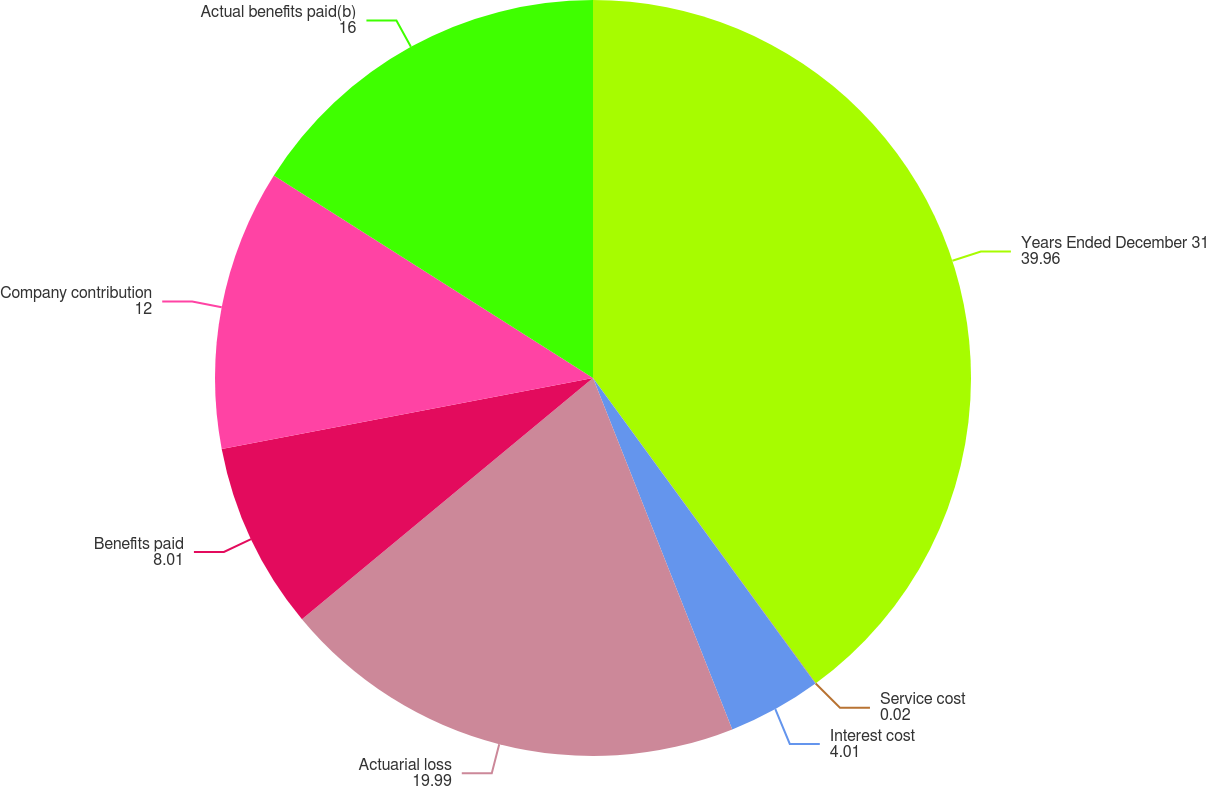Convert chart to OTSL. <chart><loc_0><loc_0><loc_500><loc_500><pie_chart><fcel>Years Ended December 31<fcel>Service cost<fcel>Interest cost<fcel>Actuarial loss<fcel>Benefits paid<fcel>Company contribution<fcel>Actual benefits paid(b)<nl><fcel>39.96%<fcel>0.02%<fcel>4.01%<fcel>19.99%<fcel>8.01%<fcel>12.0%<fcel>16.0%<nl></chart> 